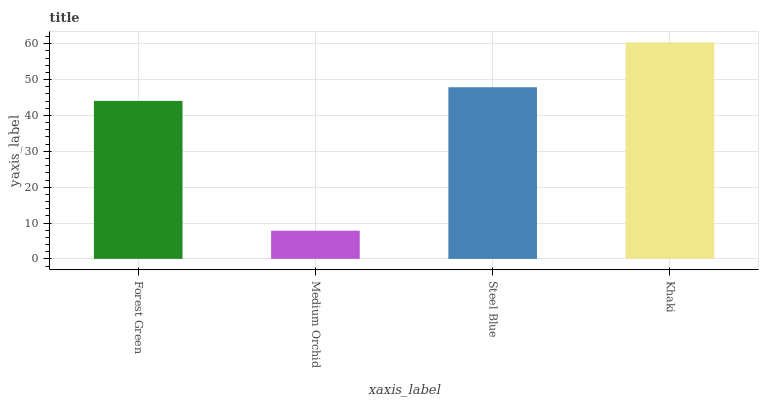Is Medium Orchid the minimum?
Answer yes or no. Yes. Is Khaki the maximum?
Answer yes or no. Yes. Is Steel Blue the minimum?
Answer yes or no. No. Is Steel Blue the maximum?
Answer yes or no. No. Is Steel Blue greater than Medium Orchid?
Answer yes or no. Yes. Is Medium Orchid less than Steel Blue?
Answer yes or no. Yes. Is Medium Orchid greater than Steel Blue?
Answer yes or no. No. Is Steel Blue less than Medium Orchid?
Answer yes or no. No. Is Steel Blue the high median?
Answer yes or no. Yes. Is Forest Green the low median?
Answer yes or no. Yes. Is Forest Green the high median?
Answer yes or no. No. Is Khaki the low median?
Answer yes or no. No. 